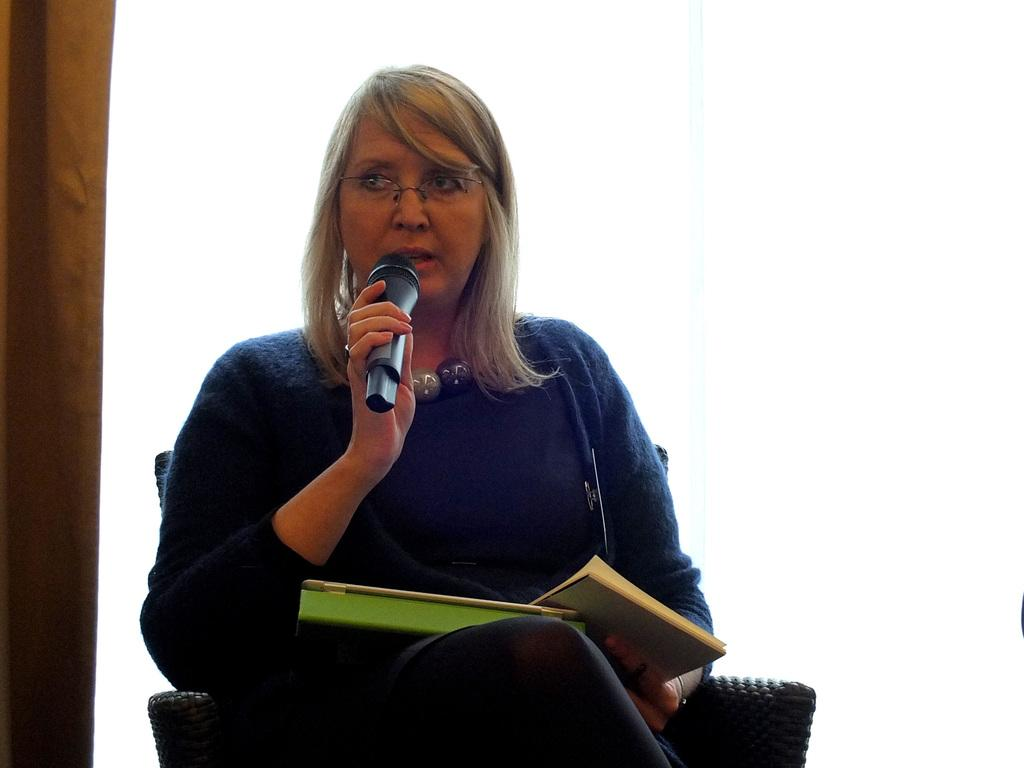Who is the main subject in the image? There is a woman in the image. What is the woman doing in the image? The woman is sitting in a chair and speaking with a mic. What else is the woman holding in the image? The woman is holding two books. What type of shock can be seen affecting the woman in the image? There is no shock present in the image; the woman is sitting calmly in a chair. What color is the gold object the woman is holding in the image? There is no gold object present in the image; the woman is holding two books. 